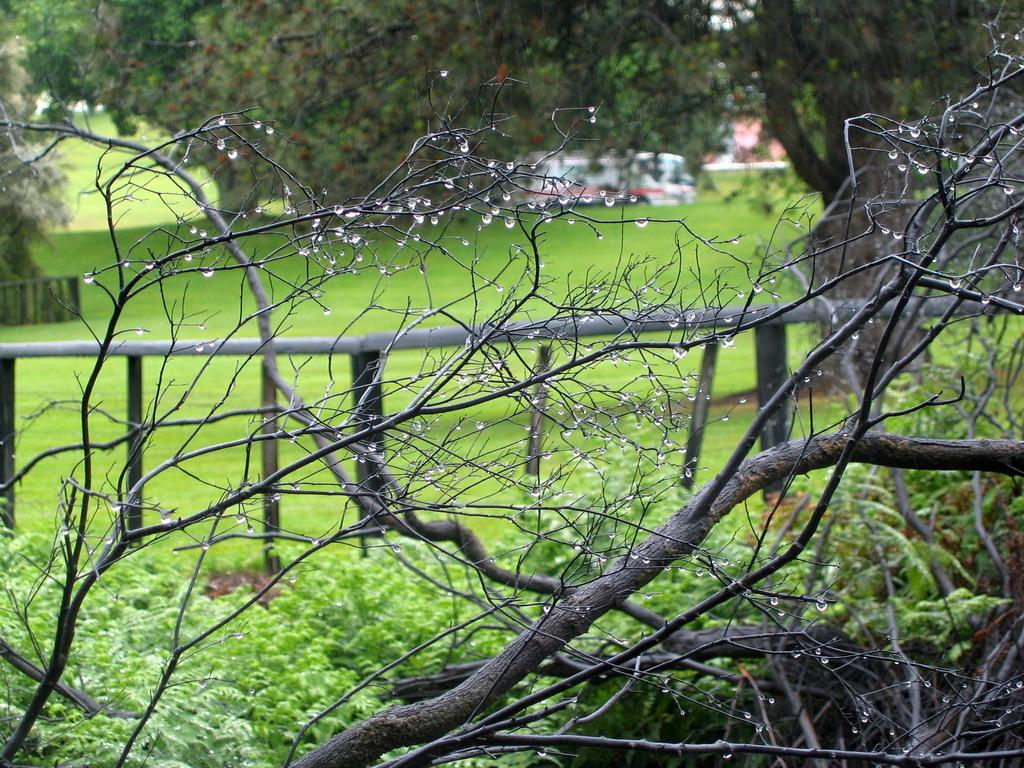What type of vegetation is present in the image? There is grass and plants visible in the image. Where are the plants located in the image? The plants are at the bottom of the image. What can be seen in the background of the image? There are trees in the background of the image. What material is visible in the image? Wood is visible in the image. What type of instrument is being played by the person in the image? There is no person or instrument present in the image. 